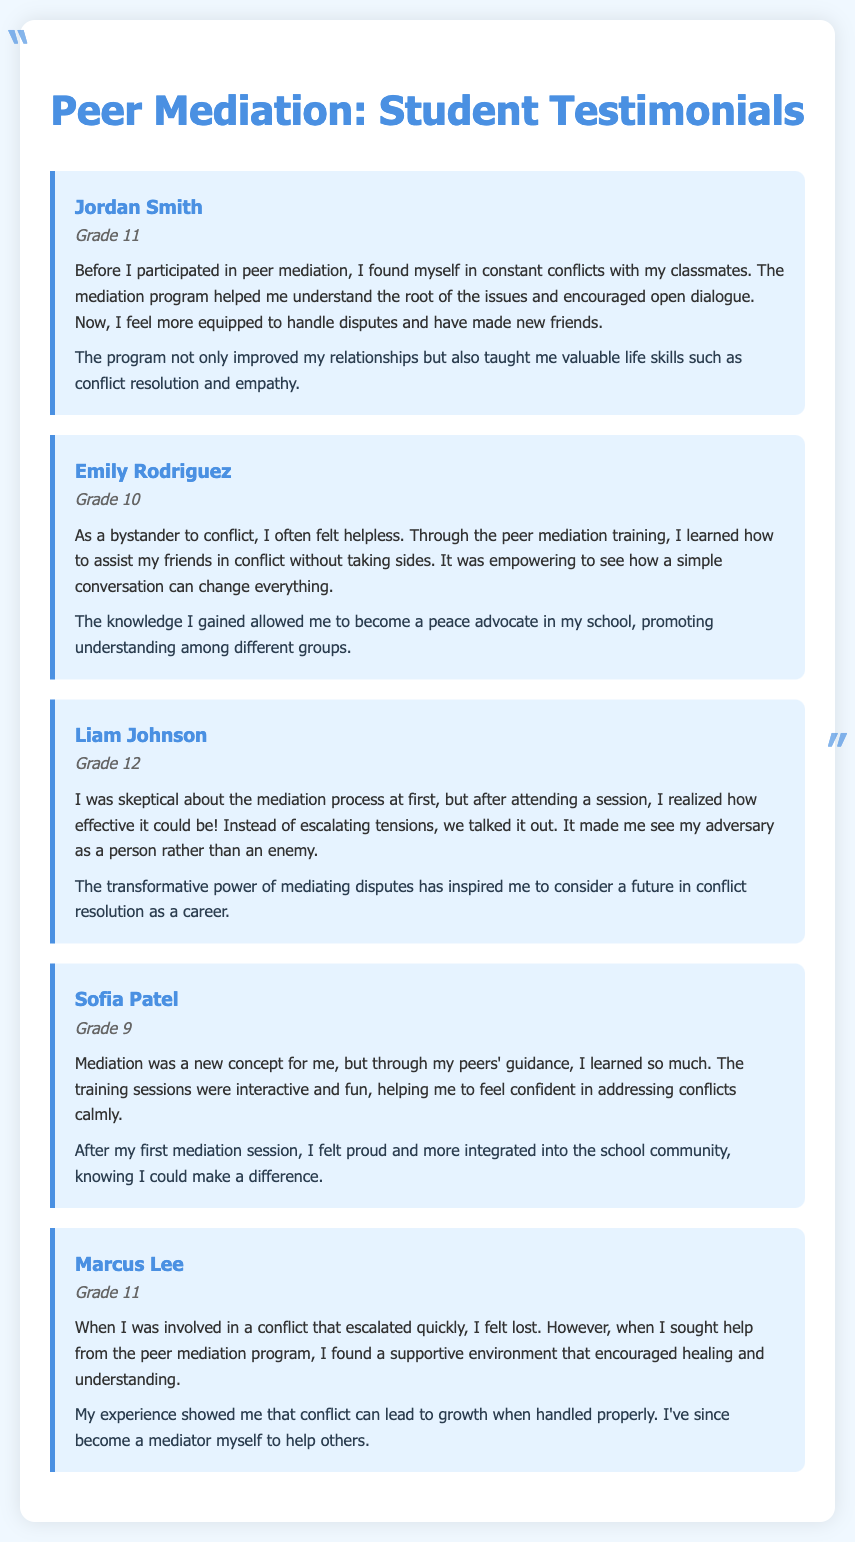What is the name of the first student testimonial? The first student testimonial is from Jordan Smith.
Answer: Jordan Smith What grade is Emily Rodriguez in? Emily Rodriguez is in Grade 10.
Answer: Grade 10 What life skills did Jordan Smith mention learning from the program? Jordan Smith mentioned learning conflict resolution and empathy.
Answer: Conflict resolution and empathy Which student expressed skepticism before attending a mediation session? Liam Johnson expressed skepticism before attending a mediation session.
Answer: Liam Johnson What impact did Sofia Patel feel after her first mediation session? Sofia Patel felt proud and more integrated into the school community.
Answer: Proud and more integrated How many testimonials are included in the document? There are five testimonials included in the document.
Answer: Five What was Marcus Lee’s feeling at the beginning of his conflict? Marcus Lee felt lost at the beginning of his conflict.
Answer: Lost Who became a peace advocate after peer mediation training? Emily Rodriguez became a peace advocate after peer mediation training.
Answer: Emily Rodriguez What is a key theme reflected in the testimonials? A key theme reflected is personal growth through conflict resolution.
Answer: Personal growth through conflict resolution 